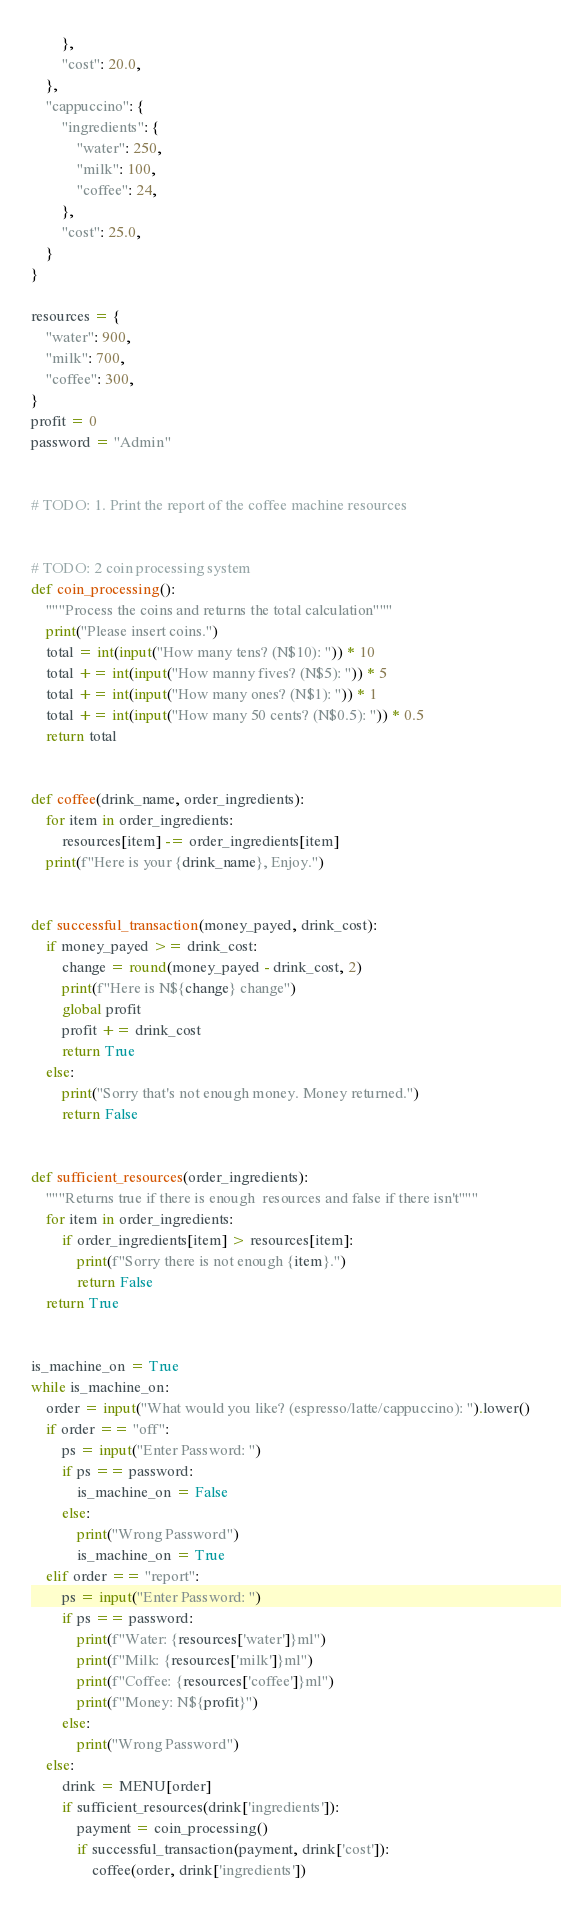<code> <loc_0><loc_0><loc_500><loc_500><_Python_>        },
        "cost": 20.0,
    },
    "cappuccino": {
        "ingredients": {
            "water": 250,
            "milk": 100,
            "coffee": 24,
        },
        "cost": 25.0,
    }
}

resources = {
    "water": 900,
    "milk": 700,
    "coffee": 300,
}
profit = 0
password = "Admin"


# TODO: 1. Print the report of the coffee machine resources


# TODO: 2 coin processing system
def coin_processing():
    """Process the coins and returns the total calculation"""
    print("Please insert coins.")
    total = int(input("How many tens? (N$10): ")) * 10
    total += int(input("How manny fives? (N$5): ")) * 5
    total += int(input("How many ones? (N$1): ")) * 1
    total += int(input("How many 50 cents? (N$0.5): ")) * 0.5
    return total


def coffee(drink_name, order_ingredients):
    for item in order_ingredients:
        resources[item] -= order_ingredients[item]
    print(f"Here is your {drink_name}, Enjoy.")


def successful_transaction(money_payed, drink_cost):
    if money_payed >= drink_cost:
        change = round(money_payed - drink_cost, 2)
        print(f"Here is N${change} change")
        global profit
        profit += drink_cost
        return True
    else:
        print("Sorry that's not enough money. Money returned.")
        return False


def sufficient_resources(order_ingredients):
    """Returns true if there is enough  resources and false if there isn't"""
    for item in order_ingredients:
        if order_ingredients[item] > resources[item]:
            print(f"Sorry there is not enough {item}.")
            return False
    return True


is_machine_on = True
while is_machine_on:
    order = input("What would you like? (espresso/latte/cappuccino): ").lower()
    if order == "off":
        ps = input("Enter Password: ")
        if ps == password:
            is_machine_on = False
        else:
            print("Wrong Password")
            is_machine_on = True
    elif order == "report":
        ps = input("Enter Password: ")
        if ps == password:
            print(f"Water: {resources['water']}ml")
            print(f"Milk: {resources['milk']}ml")
            print(f"Coffee: {resources['coffee']}ml")
            print(f"Money: N${profit}")
        else:
            print("Wrong Password")
    else:
        drink = MENU[order]
        if sufficient_resources(drink['ingredients']):
            payment = coin_processing()
            if successful_transaction(payment, drink['cost']):
                coffee(order, drink['ingredients'])
</code> 